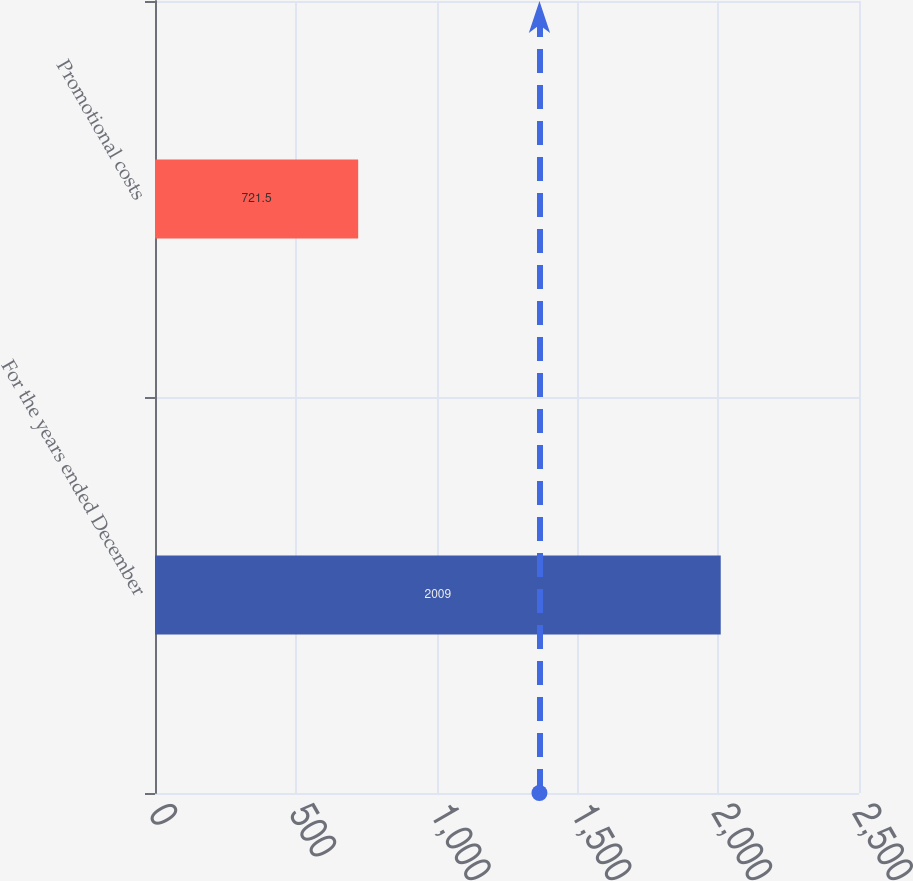Convert chart to OTSL. <chart><loc_0><loc_0><loc_500><loc_500><bar_chart><fcel>For the years ended December<fcel>Promotional costs<nl><fcel>2009<fcel>721.5<nl></chart> 